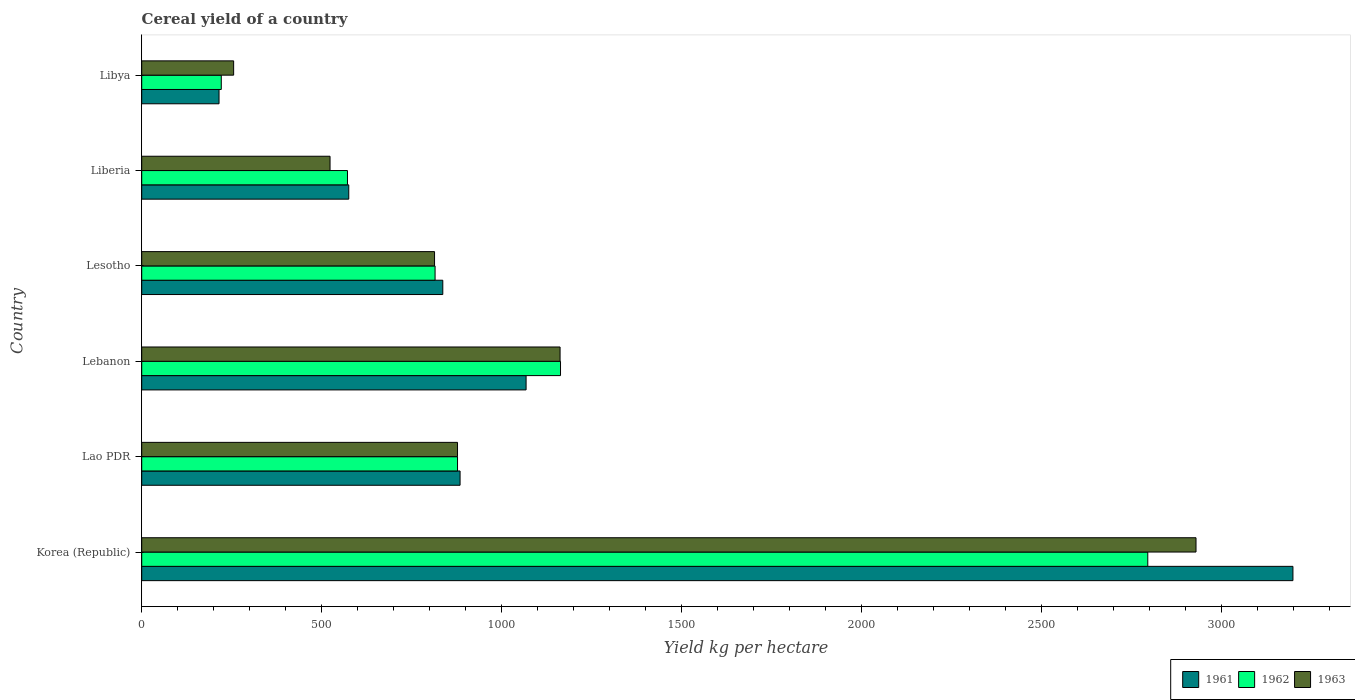How many bars are there on the 6th tick from the top?
Provide a short and direct response. 3. What is the label of the 2nd group of bars from the top?
Keep it short and to the point. Liberia. In how many cases, is the number of bars for a given country not equal to the number of legend labels?
Your response must be concise. 0. What is the total cereal yield in 1961 in Lebanon?
Keep it short and to the point. 1067.48. Across all countries, what is the maximum total cereal yield in 1962?
Your response must be concise. 2794.06. Across all countries, what is the minimum total cereal yield in 1962?
Your answer should be very brief. 220.96. In which country was the total cereal yield in 1961 minimum?
Provide a short and direct response. Libya. What is the total total cereal yield in 1963 in the graph?
Make the answer very short. 6558.47. What is the difference between the total cereal yield in 1963 in Lao PDR and that in Lesotho?
Provide a succinct answer. 63.8. What is the difference between the total cereal yield in 1961 in Lesotho and the total cereal yield in 1963 in Lebanon?
Ensure brevity in your answer.  -325.71. What is the average total cereal yield in 1961 per country?
Offer a very short reply. 1129.11. What is the difference between the total cereal yield in 1962 and total cereal yield in 1963 in Lebanon?
Offer a terse response. 1.22. What is the ratio of the total cereal yield in 1962 in Korea (Republic) to that in Lebanon?
Offer a very short reply. 2.4. Is the total cereal yield in 1962 in Lebanon less than that in Liberia?
Ensure brevity in your answer.  No. What is the difference between the highest and the second highest total cereal yield in 1962?
Provide a succinct answer. 1630.97. What is the difference between the highest and the lowest total cereal yield in 1963?
Keep it short and to the point. 2672.76. In how many countries, is the total cereal yield in 1963 greater than the average total cereal yield in 1963 taken over all countries?
Offer a terse response. 2. What does the 2nd bar from the bottom in Korea (Republic) represents?
Offer a very short reply. 1962. Is it the case that in every country, the sum of the total cereal yield in 1962 and total cereal yield in 1963 is greater than the total cereal yield in 1961?
Keep it short and to the point. Yes. How many bars are there?
Your response must be concise. 18. Are all the bars in the graph horizontal?
Provide a short and direct response. Yes. How many countries are there in the graph?
Ensure brevity in your answer.  6. What is the difference between two consecutive major ticks on the X-axis?
Keep it short and to the point. 500. Does the graph contain any zero values?
Give a very brief answer. No. How many legend labels are there?
Ensure brevity in your answer.  3. What is the title of the graph?
Offer a terse response. Cereal yield of a country. What is the label or title of the X-axis?
Your response must be concise. Yield kg per hectare. What is the Yield kg per hectare in 1961 in Korea (Republic)?
Provide a short and direct response. 3197.18. What is the Yield kg per hectare of 1962 in Korea (Republic)?
Your answer should be very brief. 2794.06. What is the Yield kg per hectare of 1963 in Korea (Republic)?
Offer a terse response. 2928.02. What is the Yield kg per hectare in 1961 in Lao PDR?
Make the answer very short. 884.13. What is the Yield kg per hectare of 1962 in Lao PDR?
Your answer should be compact. 877.08. What is the Yield kg per hectare of 1963 in Lao PDR?
Offer a very short reply. 877.05. What is the Yield kg per hectare in 1961 in Lebanon?
Your answer should be very brief. 1067.48. What is the Yield kg per hectare in 1962 in Lebanon?
Make the answer very short. 1163.09. What is the Yield kg per hectare in 1963 in Lebanon?
Ensure brevity in your answer.  1161.87. What is the Yield kg per hectare in 1961 in Lesotho?
Your response must be concise. 836.16. What is the Yield kg per hectare in 1962 in Lesotho?
Your response must be concise. 814.71. What is the Yield kg per hectare of 1963 in Lesotho?
Keep it short and to the point. 813.25. What is the Yield kg per hectare in 1961 in Liberia?
Ensure brevity in your answer.  575. What is the Yield kg per hectare of 1962 in Liberia?
Your answer should be compact. 571.43. What is the Yield kg per hectare of 1963 in Liberia?
Offer a terse response. 523.01. What is the Yield kg per hectare of 1961 in Libya?
Your response must be concise. 214.71. What is the Yield kg per hectare in 1962 in Libya?
Provide a succinct answer. 220.96. What is the Yield kg per hectare in 1963 in Libya?
Provide a succinct answer. 255.27. Across all countries, what is the maximum Yield kg per hectare in 1961?
Your answer should be compact. 3197.18. Across all countries, what is the maximum Yield kg per hectare in 1962?
Your response must be concise. 2794.06. Across all countries, what is the maximum Yield kg per hectare of 1963?
Keep it short and to the point. 2928.02. Across all countries, what is the minimum Yield kg per hectare in 1961?
Make the answer very short. 214.71. Across all countries, what is the minimum Yield kg per hectare in 1962?
Offer a very short reply. 220.96. Across all countries, what is the minimum Yield kg per hectare of 1963?
Keep it short and to the point. 255.27. What is the total Yield kg per hectare in 1961 in the graph?
Keep it short and to the point. 6774.65. What is the total Yield kg per hectare in 1962 in the graph?
Offer a very short reply. 6441.32. What is the total Yield kg per hectare of 1963 in the graph?
Your response must be concise. 6558.47. What is the difference between the Yield kg per hectare in 1961 in Korea (Republic) and that in Lao PDR?
Make the answer very short. 2313.05. What is the difference between the Yield kg per hectare of 1962 in Korea (Republic) and that in Lao PDR?
Offer a very short reply. 1916.98. What is the difference between the Yield kg per hectare of 1963 in Korea (Republic) and that in Lao PDR?
Ensure brevity in your answer.  2050.97. What is the difference between the Yield kg per hectare of 1961 in Korea (Republic) and that in Lebanon?
Your answer should be very brief. 2129.7. What is the difference between the Yield kg per hectare in 1962 in Korea (Republic) and that in Lebanon?
Your response must be concise. 1630.97. What is the difference between the Yield kg per hectare in 1963 in Korea (Republic) and that in Lebanon?
Keep it short and to the point. 1766.16. What is the difference between the Yield kg per hectare in 1961 in Korea (Republic) and that in Lesotho?
Your response must be concise. 2361.02. What is the difference between the Yield kg per hectare of 1962 in Korea (Republic) and that in Lesotho?
Your response must be concise. 1979.35. What is the difference between the Yield kg per hectare in 1963 in Korea (Republic) and that in Lesotho?
Offer a very short reply. 2114.77. What is the difference between the Yield kg per hectare of 1961 in Korea (Republic) and that in Liberia?
Offer a very short reply. 2622.18. What is the difference between the Yield kg per hectare of 1962 in Korea (Republic) and that in Liberia?
Make the answer very short. 2222.63. What is the difference between the Yield kg per hectare in 1963 in Korea (Republic) and that in Liberia?
Your answer should be compact. 2405.01. What is the difference between the Yield kg per hectare of 1961 in Korea (Republic) and that in Libya?
Ensure brevity in your answer.  2982.47. What is the difference between the Yield kg per hectare in 1962 in Korea (Republic) and that in Libya?
Your answer should be very brief. 2573.1. What is the difference between the Yield kg per hectare in 1963 in Korea (Republic) and that in Libya?
Provide a short and direct response. 2672.76. What is the difference between the Yield kg per hectare in 1961 in Lao PDR and that in Lebanon?
Your answer should be compact. -183.35. What is the difference between the Yield kg per hectare of 1962 in Lao PDR and that in Lebanon?
Provide a succinct answer. -286.01. What is the difference between the Yield kg per hectare in 1963 in Lao PDR and that in Lebanon?
Give a very brief answer. -284.82. What is the difference between the Yield kg per hectare of 1961 in Lao PDR and that in Lesotho?
Give a very brief answer. 47.97. What is the difference between the Yield kg per hectare in 1962 in Lao PDR and that in Lesotho?
Offer a very short reply. 62.37. What is the difference between the Yield kg per hectare in 1963 in Lao PDR and that in Lesotho?
Give a very brief answer. 63.8. What is the difference between the Yield kg per hectare in 1961 in Lao PDR and that in Liberia?
Make the answer very short. 309.13. What is the difference between the Yield kg per hectare of 1962 in Lao PDR and that in Liberia?
Give a very brief answer. 305.65. What is the difference between the Yield kg per hectare in 1963 in Lao PDR and that in Liberia?
Provide a short and direct response. 354.04. What is the difference between the Yield kg per hectare of 1961 in Lao PDR and that in Libya?
Ensure brevity in your answer.  669.42. What is the difference between the Yield kg per hectare of 1962 in Lao PDR and that in Libya?
Provide a succinct answer. 656.12. What is the difference between the Yield kg per hectare in 1963 in Lao PDR and that in Libya?
Keep it short and to the point. 621.78. What is the difference between the Yield kg per hectare in 1961 in Lebanon and that in Lesotho?
Keep it short and to the point. 231.32. What is the difference between the Yield kg per hectare of 1962 in Lebanon and that in Lesotho?
Offer a terse response. 348.38. What is the difference between the Yield kg per hectare of 1963 in Lebanon and that in Lesotho?
Provide a succinct answer. 348.62. What is the difference between the Yield kg per hectare of 1961 in Lebanon and that in Liberia?
Your response must be concise. 492.48. What is the difference between the Yield kg per hectare in 1962 in Lebanon and that in Liberia?
Your answer should be very brief. 591.66. What is the difference between the Yield kg per hectare of 1963 in Lebanon and that in Liberia?
Keep it short and to the point. 638.85. What is the difference between the Yield kg per hectare of 1961 in Lebanon and that in Libya?
Your answer should be compact. 852.77. What is the difference between the Yield kg per hectare of 1962 in Lebanon and that in Libya?
Offer a very short reply. 942.13. What is the difference between the Yield kg per hectare of 1963 in Lebanon and that in Libya?
Offer a terse response. 906.6. What is the difference between the Yield kg per hectare of 1961 in Lesotho and that in Liberia?
Offer a terse response. 261.16. What is the difference between the Yield kg per hectare of 1962 in Lesotho and that in Liberia?
Provide a short and direct response. 243.28. What is the difference between the Yield kg per hectare in 1963 in Lesotho and that in Liberia?
Your response must be concise. 290.24. What is the difference between the Yield kg per hectare of 1961 in Lesotho and that in Libya?
Your answer should be compact. 621.45. What is the difference between the Yield kg per hectare of 1962 in Lesotho and that in Libya?
Keep it short and to the point. 593.75. What is the difference between the Yield kg per hectare of 1963 in Lesotho and that in Libya?
Provide a short and direct response. 557.98. What is the difference between the Yield kg per hectare in 1961 in Liberia and that in Libya?
Your answer should be compact. 360.29. What is the difference between the Yield kg per hectare in 1962 in Liberia and that in Libya?
Your answer should be very brief. 350.47. What is the difference between the Yield kg per hectare of 1963 in Liberia and that in Libya?
Provide a succinct answer. 267.75. What is the difference between the Yield kg per hectare in 1961 in Korea (Republic) and the Yield kg per hectare in 1962 in Lao PDR?
Provide a succinct answer. 2320.1. What is the difference between the Yield kg per hectare in 1961 in Korea (Republic) and the Yield kg per hectare in 1963 in Lao PDR?
Provide a succinct answer. 2320.13. What is the difference between the Yield kg per hectare of 1962 in Korea (Republic) and the Yield kg per hectare of 1963 in Lao PDR?
Offer a terse response. 1917.01. What is the difference between the Yield kg per hectare of 1961 in Korea (Republic) and the Yield kg per hectare of 1962 in Lebanon?
Your answer should be very brief. 2034.09. What is the difference between the Yield kg per hectare in 1961 in Korea (Republic) and the Yield kg per hectare in 1963 in Lebanon?
Provide a succinct answer. 2035.31. What is the difference between the Yield kg per hectare of 1962 in Korea (Republic) and the Yield kg per hectare of 1963 in Lebanon?
Your response must be concise. 1632.19. What is the difference between the Yield kg per hectare of 1961 in Korea (Republic) and the Yield kg per hectare of 1962 in Lesotho?
Your answer should be very brief. 2382.47. What is the difference between the Yield kg per hectare of 1961 in Korea (Republic) and the Yield kg per hectare of 1963 in Lesotho?
Your answer should be compact. 2383.93. What is the difference between the Yield kg per hectare of 1962 in Korea (Republic) and the Yield kg per hectare of 1963 in Lesotho?
Your answer should be compact. 1980.81. What is the difference between the Yield kg per hectare in 1961 in Korea (Republic) and the Yield kg per hectare in 1962 in Liberia?
Your answer should be compact. 2625.75. What is the difference between the Yield kg per hectare in 1961 in Korea (Republic) and the Yield kg per hectare in 1963 in Liberia?
Your response must be concise. 2674.16. What is the difference between the Yield kg per hectare of 1962 in Korea (Republic) and the Yield kg per hectare of 1963 in Liberia?
Offer a very short reply. 2271.05. What is the difference between the Yield kg per hectare of 1961 in Korea (Republic) and the Yield kg per hectare of 1962 in Libya?
Keep it short and to the point. 2976.22. What is the difference between the Yield kg per hectare of 1961 in Korea (Republic) and the Yield kg per hectare of 1963 in Libya?
Make the answer very short. 2941.91. What is the difference between the Yield kg per hectare of 1962 in Korea (Republic) and the Yield kg per hectare of 1963 in Libya?
Offer a terse response. 2538.79. What is the difference between the Yield kg per hectare of 1961 in Lao PDR and the Yield kg per hectare of 1962 in Lebanon?
Provide a succinct answer. -278.96. What is the difference between the Yield kg per hectare of 1961 in Lao PDR and the Yield kg per hectare of 1963 in Lebanon?
Offer a terse response. -277.74. What is the difference between the Yield kg per hectare of 1962 in Lao PDR and the Yield kg per hectare of 1963 in Lebanon?
Make the answer very short. -284.79. What is the difference between the Yield kg per hectare in 1961 in Lao PDR and the Yield kg per hectare in 1962 in Lesotho?
Offer a very short reply. 69.42. What is the difference between the Yield kg per hectare in 1961 in Lao PDR and the Yield kg per hectare in 1963 in Lesotho?
Your answer should be compact. 70.88. What is the difference between the Yield kg per hectare of 1962 in Lao PDR and the Yield kg per hectare of 1963 in Lesotho?
Keep it short and to the point. 63.83. What is the difference between the Yield kg per hectare in 1961 in Lao PDR and the Yield kg per hectare in 1962 in Liberia?
Give a very brief answer. 312.7. What is the difference between the Yield kg per hectare of 1961 in Lao PDR and the Yield kg per hectare of 1963 in Liberia?
Offer a terse response. 361.11. What is the difference between the Yield kg per hectare of 1962 in Lao PDR and the Yield kg per hectare of 1963 in Liberia?
Make the answer very short. 354.06. What is the difference between the Yield kg per hectare of 1961 in Lao PDR and the Yield kg per hectare of 1962 in Libya?
Offer a terse response. 663.17. What is the difference between the Yield kg per hectare of 1961 in Lao PDR and the Yield kg per hectare of 1963 in Libya?
Ensure brevity in your answer.  628.86. What is the difference between the Yield kg per hectare in 1962 in Lao PDR and the Yield kg per hectare in 1963 in Libya?
Your response must be concise. 621.81. What is the difference between the Yield kg per hectare in 1961 in Lebanon and the Yield kg per hectare in 1962 in Lesotho?
Offer a terse response. 252.77. What is the difference between the Yield kg per hectare of 1961 in Lebanon and the Yield kg per hectare of 1963 in Lesotho?
Your answer should be compact. 254.23. What is the difference between the Yield kg per hectare in 1962 in Lebanon and the Yield kg per hectare in 1963 in Lesotho?
Give a very brief answer. 349.84. What is the difference between the Yield kg per hectare of 1961 in Lebanon and the Yield kg per hectare of 1962 in Liberia?
Provide a short and direct response. 496.05. What is the difference between the Yield kg per hectare in 1961 in Lebanon and the Yield kg per hectare in 1963 in Liberia?
Your answer should be compact. 544.47. What is the difference between the Yield kg per hectare of 1962 in Lebanon and the Yield kg per hectare of 1963 in Liberia?
Offer a terse response. 640.08. What is the difference between the Yield kg per hectare in 1961 in Lebanon and the Yield kg per hectare in 1962 in Libya?
Keep it short and to the point. 846.52. What is the difference between the Yield kg per hectare of 1961 in Lebanon and the Yield kg per hectare of 1963 in Libya?
Provide a succinct answer. 812.21. What is the difference between the Yield kg per hectare in 1962 in Lebanon and the Yield kg per hectare in 1963 in Libya?
Your answer should be compact. 907.82. What is the difference between the Yield kg per hectare of 1961 in Lesotho and the Yield kg per hectare of 1962 in Liberia?
Ensure brevity in your answer.  264.73. What is the difference between the Yield kg per hectare of 1961 in Lesotho and the Yield kg per hectare of 1963 in Liberia?
Ensure brevity in your answer.  313.14. What is the difference between the Yield kg per hectare in 1962 in Lesotho and the Yield kg per hectare in 1963 in Liberia?
Your answer should be very brief. 291.69. What is the difference between the Yield kg per hectare of 1961 in Lesotho and the Yield kg per hectare of 1962 in Libya?
Give a very brief answer. 615.2. What is the difference between the Yield kg per hectare of 1961 in Lesotho and the Yield kg per hectare of 1963 in Libya?
Keep it short and to the point. 580.89. What is the difference between the Yield kg per hectare of 1962 in Lesotho and the Yield kg per hectare of 1963 in Libya?
Provide a short and direct response. 559.44. What is the difference between the Yield kg per hectare in 1961 in Liberia and the Yield kg per hectare in 1962 in Libya?
Keep it short and to the point. 354.04. What is the difference between the Yield kg per hectare in 1961 in Liberia and the Yield kg per hectare in 1963 in Libya?
Provide a succinct answer. 319.73. What is the difference between the Yield kg per hectare of 1962 in Liberia and the Yield kg per hectare of 1963 in Libya?
Your answer should be compact. 316.16. What is the average Yield kg per hectare in 1961 per country?
Make the answer very short. 1129.11. What is the average Yield kg per hectare in 1962 per country?
Provide a short and direct response. 1073.55. What is the average Yield kg per hectare of 1963 per country?
Your response must be concise. 1093.08. What is the difference between the Yield kg per hectare in 1961 and Yield kg per hectare in 1962 in Korea (Republic)?
Provide a succinct answer. 403.12. What is the difference between the Yield kg per hectare in 1961 and Yield kg per hectare in 1963 in Korea (Republic)?
Provide a short and direct response. 269.15. What is the difference between the Yield kg per hectare in 1962 and Yield kg per hectare in 1963 in Korea (Republic)?
Keep it short and to the point. -133.97. What is the difference between the Yield kg per hectare in 1961 and Yield kg per hectare in 1962 in Lao PDR?
Make the answer very short. 7.05. What is the difference between the Yield kg per hectare in 1961 and Yield kg per hectare in 1963 in Lao PDR?
Your answer should be compact. 7.08. What is the difference between the Yield kg per hectare in 1962 and Yield kg per hectare in 1963 in Lao PDR?
Your response must be concise. 0.03. What is the difference between the Yield kg per hectare of 1961 and Yield kg per hectare of 1962 in Lebanon?
Your answer should be compact. -95.61. What is the difference between the Yield kg per hectare of 1961 and Yield kg per hectare of 1963 in Lebanon?
Your answer should be compact. -94.39. What is the difference between the Yield kg per hectare in 1962 and Yield kg per hectare in 1963 in Lebanon?
Your answer should be compact. 1.22. What is the difference between the Yield kg per hectare in 1961 and Yield kg per hectare in 1962 in Lesotho?
Your answer should be very brief. 21.45. What is the difference between the Yield kg per hectare in 1961 and Yield kg per hectare in 1963 in Lesotho?
Give a very brief answer. 22.91. What is the difference between the Yield kg per hectare of 1962 and Yield kg per hectare of 1963 in Lesotho?
Keep it short and to the point. 1.46. What is the difference between the Yield kg per hectare of 1961 and Yield kg per hectare of 1962 in Liberia?
Offer a terse response. 3.57. What is the difference between the Yield kg per hectare of 1961 and Yield kg per hectare of 1963 in Liberia?
Offer a very short reply. 51.99. What is the difference between the Yield kg per hectare in 1962 and Yield kg per hectare in 1963 in Liberia?
Your answer should be compact. 48.42. What is the difference between the Yield kg per hectare of 1961 and Yield kg per hectare of 1962 in Libya?
Offer a very short reply. -6.25. What is the difference between the Yield kg per hectare in 1961 and Yield kg per hectare in 1963 in Libya?
Your response must be concise. -40.56. What is the difference between the Yield kg per hectare in 1962 and Yield kg per hectare in 1963 in Libya?
Ensure brevity in your answer.  -34.31. What is the ratio of the Yield kg per hectare of 1961 in Korea (Republic) to that in Lao PDR?
Your answer should be very brief. 3.62. What is the ratio of the Yield kg per hectare in 1962 in Korea (Republic) to that in Lao PDR?
Your answer should be very brief. 3.19. What is the ratio of the Yield kg per hectare in 1963 in Korea (Republic) to that in Lao PDR?
Provide a short and direct response. 3.34. What is the ratio of the Yield kg per hectare of 1961 in Korea (Republic) to that in Lebanon?
Offer a very short reply. 3. What is the ratio of the Yield kg per hectare of 1962 in Korea (Republic) to that in Lebanon?
Offer a terse response. 2.4. What is the ratio of the Yield kg per hectare in 1963 in Korea (Republic) to that in Lebanon?
Your answer should be compact. 2.52. What is the ratio of the Yield kg per hectare in 1961 in Korea (Republic) to that in Lesotho?
Provide a succinct answer. 3.82. What is the ratio of the Yield kg per hectare in 1962 in Korea (Republic) to that in Lesotho?
Provide a short and direct response. 3.43. What is the ratio of the Yield kg per hectare of 1963 in Korea (Republic) to that in Lesotho?
Ensure brevity in your answer.  3.6. What is the ratio of the Yield kg per hectare in 1961 in Korea (Republic) to that in Liberia?
Your answer should be very brief. 5.56. What is the ratio of the Yield kg per hectare in 1962 in Korea (Republic) to that in Liberia?
Your response must be concise. 4.89. What is the ratio of the Yield kg per hectare of 1963 in Korea (Republic) to that in Liberia?
Provide a short and direct response. 5.6. What is the ratio of the Yield kg per hectare in 1961 in Korea (Republic) to that in Libya?
Ensure brevity in your answer.  14.89. What is the ratio of the Yield kg per hectare of 1962 in Korea (Republic) to that in Libya?
Make the answer very short. 12.65. What is the ratio of the Yield kg per hectare of 1963 in Korea (Republic) to that in Libya?
Your answer should be compact. 11.47. What is the ratio of the Yield kg per hectare in 1961 in Lao PDR to that in Lebanon?
Your answer should be compact. 0.83. What is the ratio of the Yield kg per hectare in 1962 in Lao PDR to that in Lebanon?
Ensure brevity in your answer.  0.75. What is the ratio of the Yield kg per hectare in 1963 in Lao PDR to that in Lebanon?
Make the answer very short. 0.75. What is the ratio of the Yield kg per hectare in 1961 in Lao PDR to that in Lesotho?
Give a very brief answer. 1.06. What is the ratio of the Yield kg per hectare in 1962 in Lao PDR to that in Lesotho?
Keep it short and to the point. 1.08. What is the ratio of the Yield kg per hectare in 1963 in Lao PDR to that in Lesotho?
Ensure brevity in your answer.  1.08. What is the ratio of the Yield kg per hectare of 1961 in Lao PDR to that in Liberia?
Give a very brief answer. 1.54. What is the ratio of the Yield kg per hectare in 1962 in Lao PDR to that in Liberia?
Your answer should be very brief. 1.53. What is the ratio of the Yield kg per hectare in 1963 in Lao PDR to that in Liberia?
Your answer should be very brief. 1.68. What is the ratio of the Yield kg per hectare of 1961 in Lao PDR to that in Libya?
Your response must be concise. 4.12. What is the ratio of the Yield kg per hectare of 1962 in Lao PDR to that in Libya?
Your response must be concise. 3.97. What is the ratio of the Yield kg per hectare of 1963 in Lao PDR to that in Libya?
Provide a succinct answer. 3.44. What is the ratio of the Yield kg per hectare of 1961 in Lebanon to that in Lesotho?
Your answer should be very brief. 1.28. What is the ratio of the Yield kg per hectare of 1962 in Lebanon to that in Lesotho?
Give a very brief answer. 1.43. What is the ratio of the Yield kg per hectare in 1963 in Lebanon to that in Lesotho?
Provide a succinct answer. 1.43. What is the ratio of the Yield kg per hectare in 1961 in Lebanon to that in Liberia?
Ensure brevity in your answer.  1.86. What is the ratio of the Yield kg per hectare in 1962 in Lebanon to that in Liberia?
Ensure brevity in your answer.  2.04. What is the ratio of the Yield kg per hectare in 1963 in Lebanon to that in Liberia?
Keep it short and to the point. 2.22. What is the ratio of the Yield kg per hectare of 1961 in Lebanon to that in Libya?
Your response must be concise. 4.97. What is the ratio of the Yield kg per hectare in 1962 in Lebanon to that in Libya?
Offer a very short reply. 5.26. What is the ratio of the Yield kg per hectare in 1963 in Lebanon to that in Libya?
Keep it short and to the point. 4.55. What is the ratio of the Yield kg per hectare in 1961 in Lesotho to that in Liberia?
Keep it short and to the point. 1.45. What is the ratio of the Yield kg per hectare of 1962 in Lesotho to that in Liberia?
Give a very brief answer. 1.43. What is the ratio of the Yield kg per hectare of 1963 in Lesotho to that in Liberia?
Make the answer very short. 1.55. What is the ratio of the Yield kg per hectare in 1961 in Lesotho to that in Libya?
Provide a short and direct response. 3.89. What is the ratio of the Yield kg per hectare in 1962 in Lesotho to that in Libya?
Give a very brief answer. 3.69. What is the ratio of the Yield kg per hectare of 1963 in Lesotho to that in Libya?
Your answer should be compact. 3.19. What is the ratio of the Yield kg per hectare of 1961 in Liberia to that in Libya?
Ensure brevity in your answer.  2.68. What is the ratio of the Yield kg per hectare in 1962 in Liberia to that in Libya?
Give a very brief answer. 2.59. What is the ratio of the Yield kg per hectare in 1963 in Liberia to that in Libya?
Your response must be concise. 2.05. What is the difference between the highest and the second highest Yield kg per hectare of 1961?
Your response must be concise. 2129.7. What is the difference between the highest and the second highest Yield kg per hectare of 1962?
Provide a succinct answer. 1630.97. What is the difference between the highest and the second highest Yield kg per hectare in 1963?
Keep it short and to the point. 1766.16. What is the difference between the highest and the lowest Yield kg per hectare in 1961?
Your response must be concise. 2982.47. What is the difference between the highest and the lowest Yield kg per hectare in 1962?
Your answer should be compact. 2573.1. What is the difference between the highest and the lowest Yield kg per hectare in 1963?
Provide a short and direct response. 2672.76. 